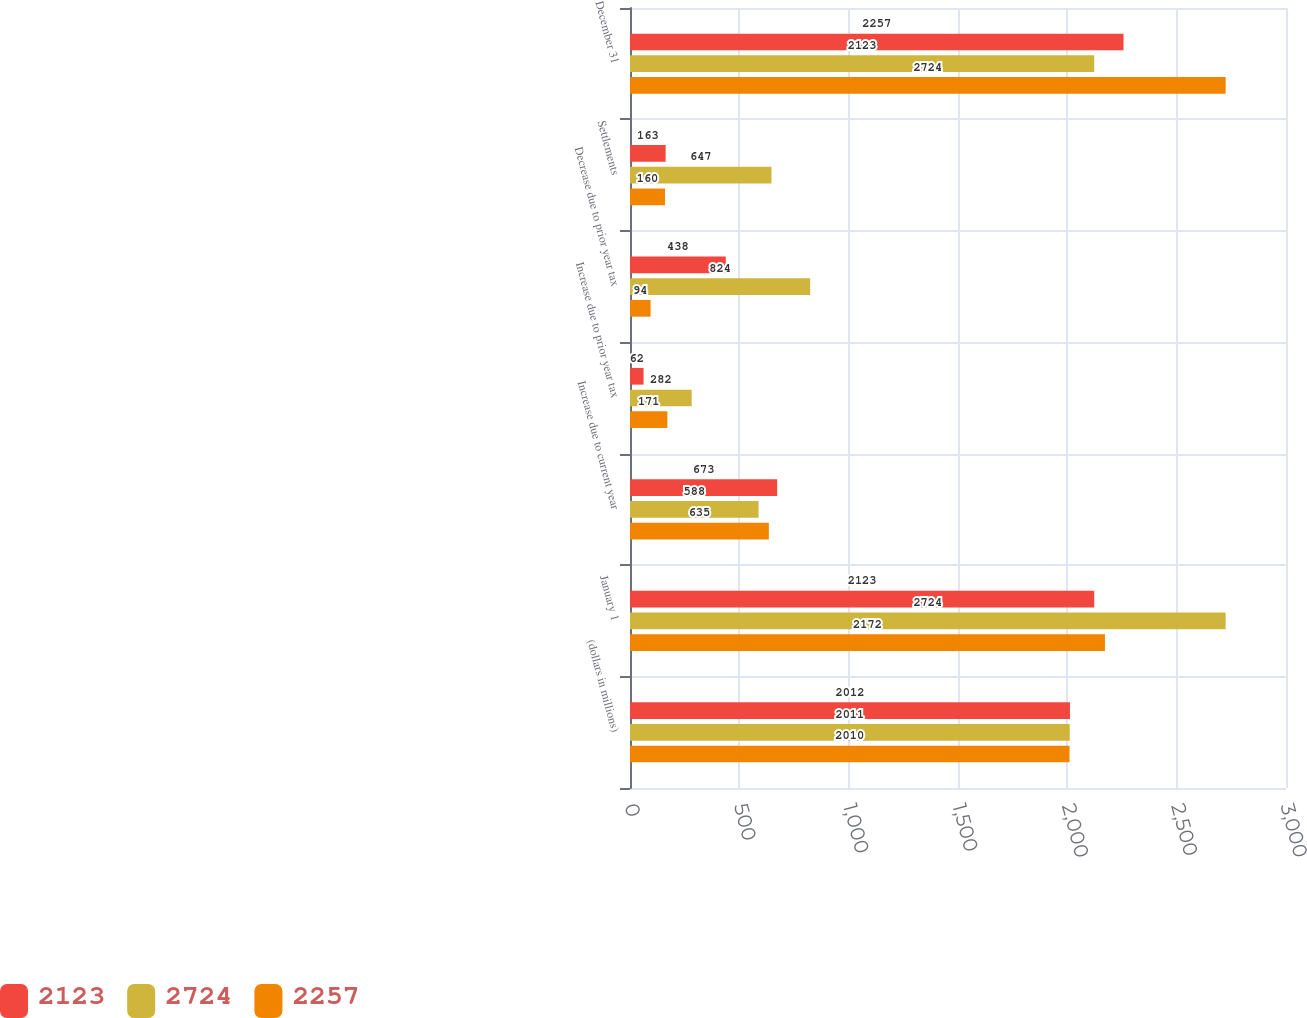<chart> <loc_0><loc_0><loc_500><loc_500><stacked_bar_chart><ecel><fcel>(dollars in millions)<fcel>January 1<fcel>Increase due to current year<fcel>Increase due to prior year tax<fcel>Decrease due to prior year tax<fcel>Settlements<fcel>December 31<nl><fcel>2123<fcel>2012<fcel>2123<fcel>673<fcel>62<fcel>438<fcel>163<fcel>2257<nl><fcel>2724<fcel>2011<fcel>2724<fcel>588<fcel>282<fcel>824<fcel>647<fcel>2123<nl><fcel>2257<fcel>2010<fcel>2172<fcel>635<fcel>171<fcel>94<fcel>160<fcel>2724<nl></chart> 